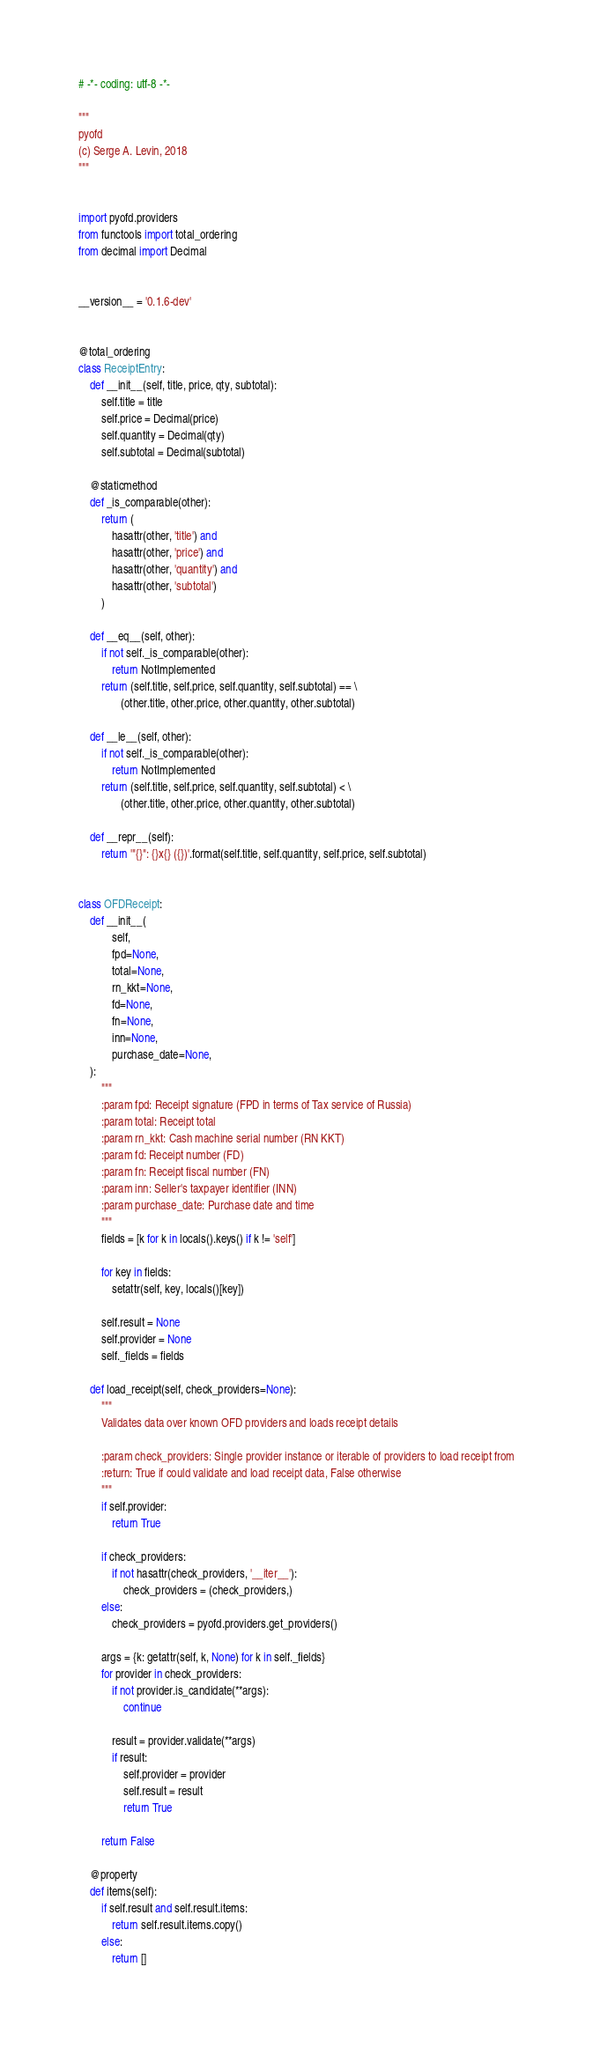Convert code to text. <code><loc_0><loc_0><loc_500><loc_500><_Python_># -*- coding: utf-8 -*-

"""
pyofd
(c) Serge A. Levin, 2018
"""


import pyofd.providers
from functools import total_ordering
from decimal import Decimal


__version__ = '0.1.6-dev'


@total_ordering
class ReceiptEntry:
    def __init__(self, title, price, qty, subtotal):
        self.title = title
        self.price = Decimal(price)
        self.quantity = Decimal(qty)
        self.subtotal = Decimal(subtotal)

    @staticmethod
    def _is_comparable(other):
        return (
            hasattr(other, 'title') and
            hasattr(other, 'price') and
            hasattr(other, 'quantity') and
            hasattr(other, 'subtotal')
        )

    def __eq__(self, other):
        if not self._is_comparable(other):
            return NotImplemented
        return (self.title, self.price, self.quantity, self.subtotal) == \
               (other.title, other.price, other.quantity, other.subtotal)

    def __le__(self, other):
        if not self._is_comparable(other):
            return NotImplemented
        return (self.title, self.price, self.quantity, self.subtotal) < \
               (other.title, other.price, other.quantity, other.subtotal)

    def __repr__(self):
        return '"{}": {}x{} ({})'.format(self.title, self.quantity, self.price, self.subtotal)


class OFDReceipt:
    def __init__(
            self,
            fpd=None,
            total=None,
            rn_kkt=None,
            fd=None,
            fn=None,
            inn=None,
            purchase_date=None,
    ):
        """
        :param fpd: Receipt signature (FPD in terms of Tax service of Russia)
        :param total: Receipt total
        :param rn_kkt: Cash machine serial number (RN KKT)
        :param fd: Receipt number (FD)
        :param fn: Receipt fiscal number (FN)
        :param inn: Seller's taxpayer identifier (INN)
        :param purchase_date: Purchase date and time
        """
        fields = [k for k in locals().keys() if k != 'self']

        for key in fields:
            setattr(self, key, locals()[key])

        self.result = None
        self.provider = None
        self._fields = fields

    def load_receipt(self, check_providers=None):
        """
        Validates data over known OFD providers and loads receipt details

        :param check_providers: Single provider instance or iterable of providers to load receipt from
        :return: True if could validate and load receipt data, False otherwise
        """
        if self.provider:
            return True

        if check_providers:
            if not hasattr(check_providers, '__iter__'):
                check_providers = (check_providers,)
        else:
            check_providers = pyofd.providers.get_providers()

        args = {k: getattr(self, k, None) for k in self._fields}
        for provider in check_providers:
            if not provider.is_candidate(**args):
                continue

            result = provider.validate(**args)
            if result:
                self.provider = provider
                self.result = result
                return True

        return False

    @property
    def items(self):
        if self.result and self.result.items:
            return self.result.items.copy()
        else:
            return []
</code> 